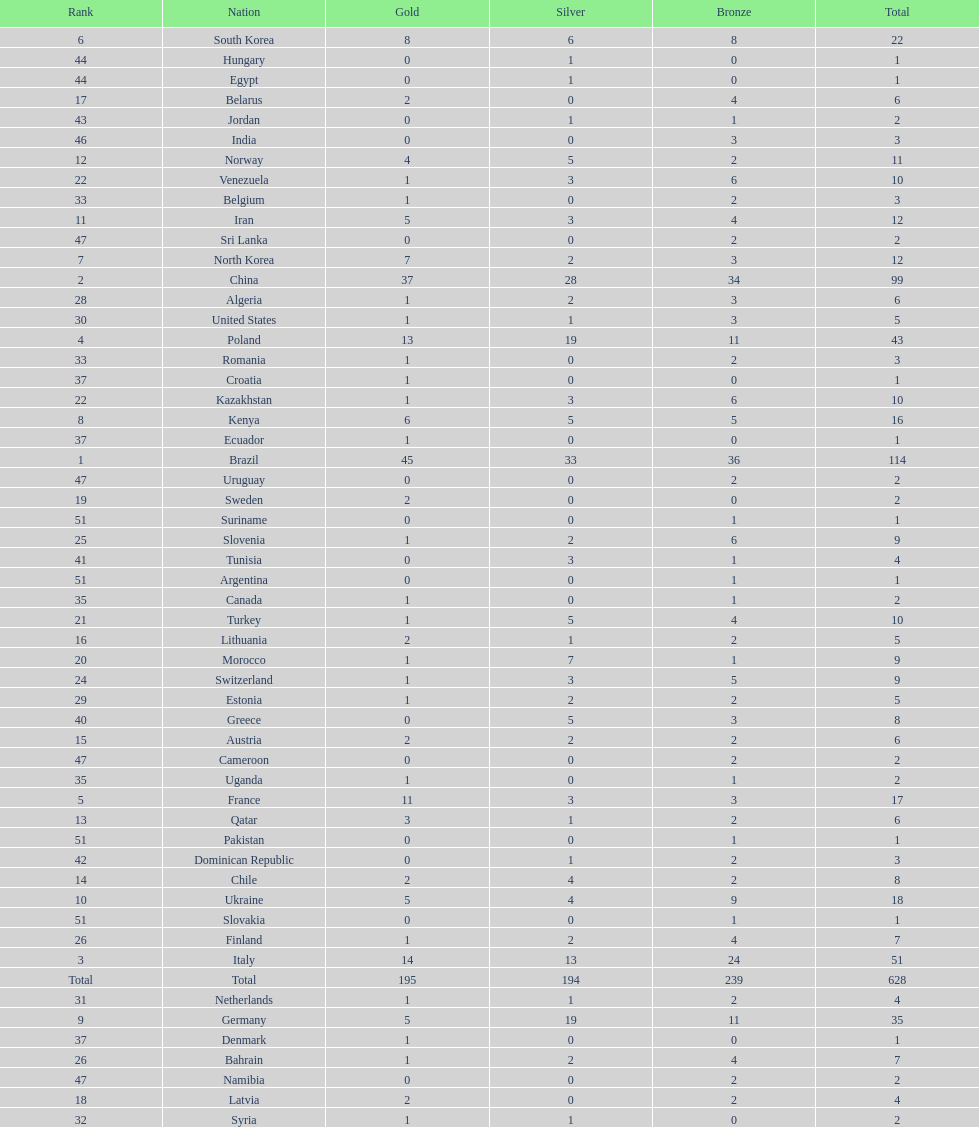Did italy or norway have 51 total medals? Italy. 